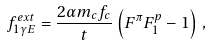<formula> <loc_0><loc_0><loc_500><loc_500>f ^ { e x t } _ { 1 \gamma E } = \frac { 2 \alpha m _ { c } f _ { c } } { t } \left ( F ^ { \pi } F _ { 1 } ^ { p } - 1 \right ) \, ,</formula> 